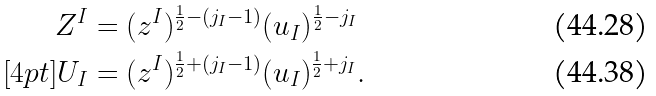<formula> <loc_0><loc_0><loc_500><loc_500>Z ^ { I } & = ( z ^ { I } ) ^ { \frac { 1 } { 2 } - ( j _ { I } - 1 ) } ( u _ { I } ) ^ { \frac { 1 } { 2 } - j _ { I } } \\ [ 4 p t ] U _ { I } & = ( z ^ { I } ) ^ { \frac { 1 } { 2 } + ( j _ { I } - 1 ) } ( u _ { I } ) ^ { \frac { 1 } { 2 } + j _ { I } } .</formula> 